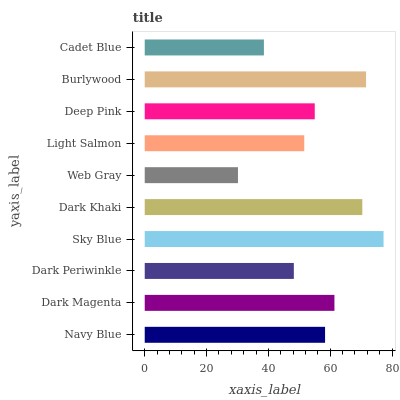Is Web Gray the minimum?
Answer yes or no. Yes. Is Sky Blue the maximum?
Answer yes or no. Yes. Is Dark Magenta the minimum?
Answer yes or no. No. Is Dark Magenta the maximum?
Answer yes or no. No. Is Dark Magenta greater than Navy Blue?
Answer yes or no. Yes. Is Navy Blue less than Dark Magenta?
Answer yes or no. Yes. Is Navy Blue greater than Dark Magenta?
Answer yes or no. No. Is Dark Magenta less than Navy Blue?
Answer yes or no. No. Is Navy Blue the high median?
Answer yes or no. Yes. Is Deep Pink the low median?
Answer yes or no. Yes. Is Cadet Blue the high median?
Answer yes or no. No. Is Navy Blue the low median?
Answer yes or no. No. 